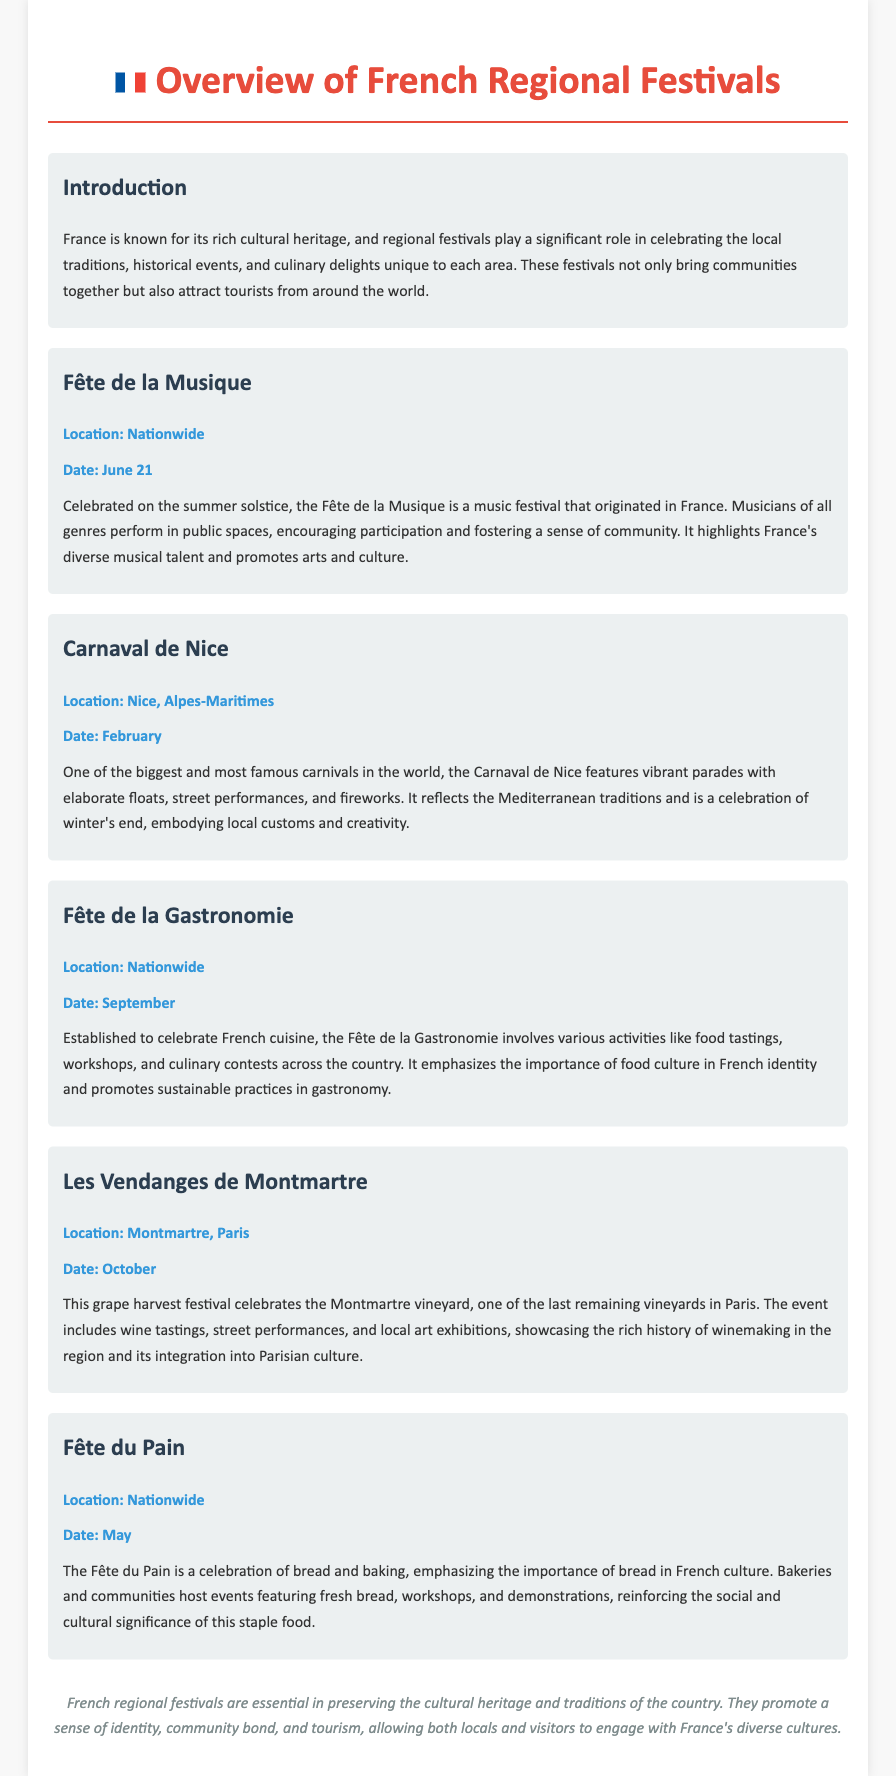What is the date of Fête de la Musique? The Fête de la Musique is celebrated on June 21.
Answer: June 21 Where is the Carnaval de Nice held? The Carnaval de Nice takes place in Nice, Alpes-Maritimes.
Answer: Nice, Alpes-Maritimes What significant theme does Fête de la Gastronomie focus on? The Fête de la Gastronomie celebrates French cuisine and food culture.
Answer: French cuisine Which festival celebrates the grape harvest in Paris? The festival that celebrates the grape harvest in Paris is Les Vendanges de Montmartre.
Answer: Les Vendanges de Montmartre What is the main food celebrated in Fête du Pain? The Fête du Pain celebrates bread and baking.
Answer: Bread Why are regional festivals important in France? Regional festivals are essential for preserving cultural heritage and promote community identity.
Answer: Cultural heritage What month is Fête de la Gastronomie celebrated? Fête de la Gastronomie is celebrated in September.
Answer: September What type of performances can be seen during Carnaval de Nice? The Carnaval de Nice features street performances and vibrant parades.
Answer: Street performances How does Fête de la Musique encourage community involvement? The festival encourages participation by allowing musicians of all genres to perform in public spaces.
Answer: Perform in public spaces 